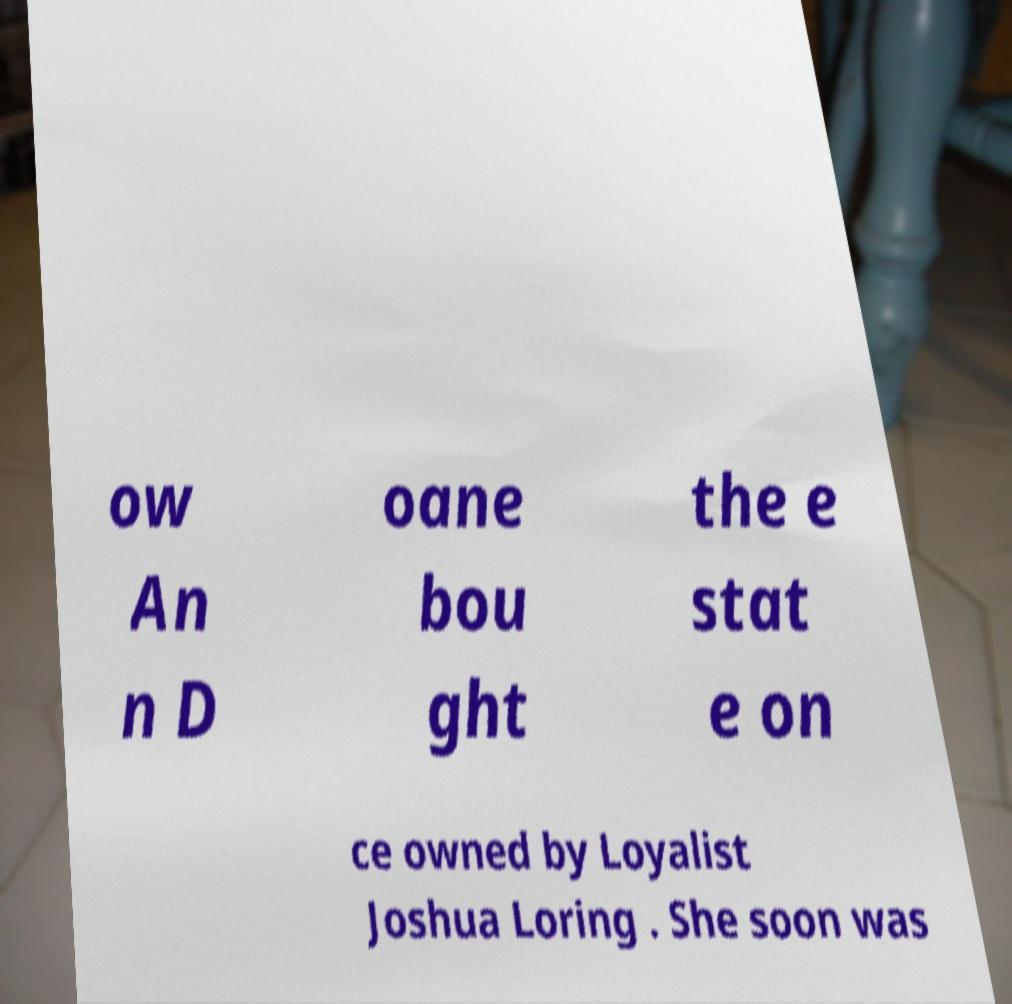Can you read and provide the text displayed in the image?This photo seems to have some interesting text. Can you extract and type it out for me? ow An n D oane bou ght the e stat e on ce owned by Loyalist Joshua Loring . She soon was 